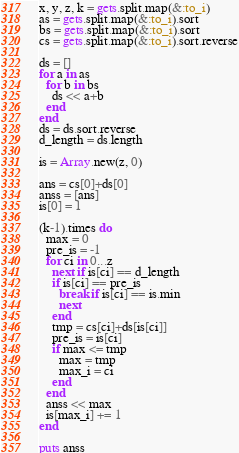<code> <loc_0><loc_0><loc_500><loc_500><_Ruby_>x, y, z, k = gets.split.map(&:to_i)
as = gets.split.map(&:to_i).sort
bs = gets.split.map(&:to_i).sort
cs = gets.split.map(&:to_i).sort.reverse

ds = []
for a in as
  for b in bs
    ds << a+b
  end
end
ds = ds.sort.reverse
d_length = ds.length

is = Array.new(z, 0)

ans = cs[0]+ds[0]
anss = [ans]
is[0] = 1

(k-1).times do
  max = 0
  pre_is = -1
  for ci in 0...z
    next if is[ci] == d_length
    if is[ci] == pre_is
      break if is[ci] == is.min
      next
    end
	tmp = cs[ci]+ds[is[ci]]
    pre_is = is[ci]
    if max <= tmp
      max = tmp
      max_i = ci
    end
  end
  anss << max
  is[max_i] += 1
end

puts anss
</code> 